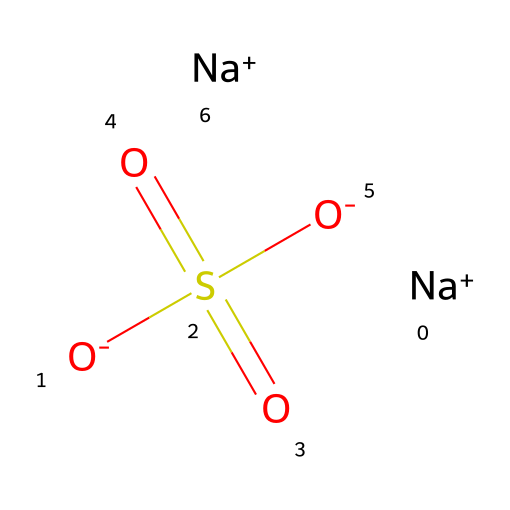What is the primary function of this compound in mummification? The structure indicates that this chemical is a salt (as suggested by the presence of sodium ions), which is commonly used to dehydrate tissues and preserve them by inhibiting bacterial growth.
Answer: preservation How many sodium atoms are present in the compound? The SMILES notation shows two instances of "[Na+]", indicating there are two sodium atoms within the chemical structure.
Answer: two What type of bonding is primarily present in this compound? The presence of ionic bonds is suggested by the separation of positively charged sodium ions and negatively charged sulfate groups, characteristic of how non-electrolytes can exhibit ionic interactions.
Answer: ionic Which functional group is responsible for its non-electrolyte nature? The "S(=O)(=O)" portion indicates the presence of a sulfate group, which is characteristic of non-electrolytes due to its inability to dissociate completely in solution compared to strong electrolytes.
Answer: sulfate What type of chemical compound is indicated by the inclusion of sulfonate groups? The presence of the sulfonate structures indicates that this compound can be categorized as a sulfonate salt, which often serves as a non-electrolyte due to its lack of dissociation in aqueous solutions.
Answer: sulfonate salt 